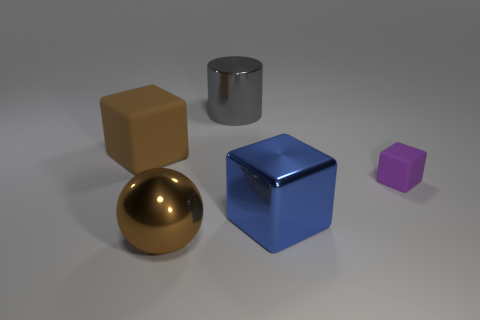Subtract all big cubes. How many cubes are left? 1 Add 4 tiny metallic spheres. How many objects exist? 9 Subtract all cubes. How many objects are left? 2 Subtract all gray cubes. Subtract all yellow balls. How many cubes are left? 3 Subtract all brown rubber objects. Subtract all large blue metal objects. How many objects are left? 3 Add 4 big gray cylinders. How many big gray cylinders are left? 5 Add 5 blue rubber blocks. How many blue rubber blocks exist? 5 Subtract 0 blue cylinders. How many objects are left? 5 